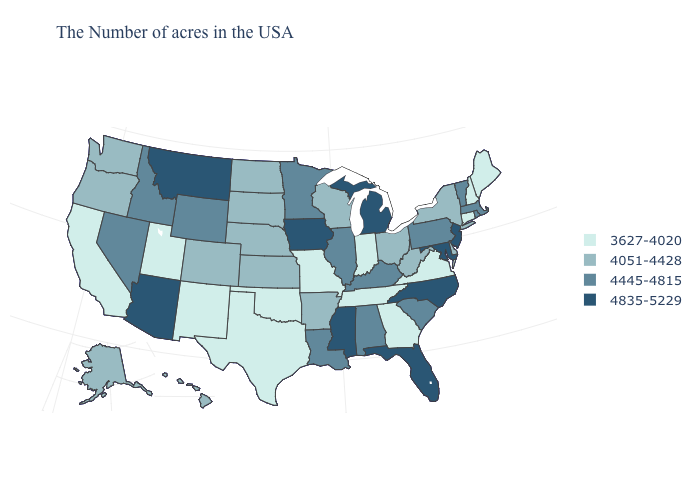Name the states that have a value in the range 4835-5229?
Quick response, please. New Jersey, Maryland, North Carolina, Florida, Michigan, Mississippi, Iowa, Montana, Arizona. What is the value of Missouri?
Give a very brief answer. 3627-4020. Name the states that have a value in the range 4445-4815?
Write a very short answer. Massachusetts, Rhode Island, Vermont, Pennsylvania, South Carolina, Kentucky, Alabama, Illinois, Louisiana, Minnesota, Wyoming, Idaho, Nevada. Which states hav the highest value in the MidWest?
Answer briefly. Michigan, Iowa. What is the value of Kentucky?
Answer briefly. 4445-4815. What is the value of Louisiana?
Concise answer only. 4445-4815. Name the states that have a value in the range 3627-4020?
Answer briefly. Maine, New Hampshire, Connecticut, Virginia, Georgia, Indiana, Tennessee, Missouri, Oklahoma, Texas, New Mexico, Utah, California. Which states have the highest value in the USA?
Write a very short answer. New Jersey, Maryland, North Carolina, Florida, Michigan, Mississippi, Iowa, Montana, Arizona. Does Arizona have the highest value in the West?
Write a very short answer. Yes. What is the lowest value in the South?
Quick response, please. 3627-4020. Among the states that border South Dakota , does Iowa have the highest value?
Keep it brief. Yes. Does Connecticut have the lowest value in the USA?
Keep it brief. Yes. What is the value of Montana?
Write a very short answer. 4835-5229. Which states have the lowest value in the USA?
Answer briefly. Maine, New Hampshire, Connecticut, Virginia, Georgia, Indiana, Tennessee, Missouri, Oklahoma, Texas, New Mexico, Utah, California. Name the states that have a value in the range 4445-4815?
Quick response, please. Massachusetts, Rhode Island, Vermont, Pennsylvania, South Carolina, Kentucky, Alabama, Illinois, Louisiana, Minnesota, Wyoming, Idaho, Nevada. 